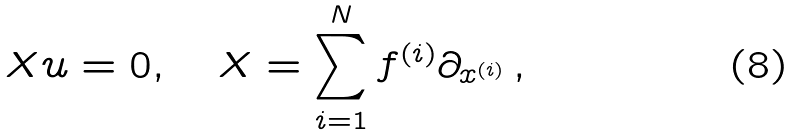<formula> <loc_0><loc_0><loc_500><loc_500>X u = 0 , \quad X = \sum _ { i = 1 } ^ { N } f ^ { ( i ) } \partial _ { x ^ { ( i ) } } \, ,</formula> 